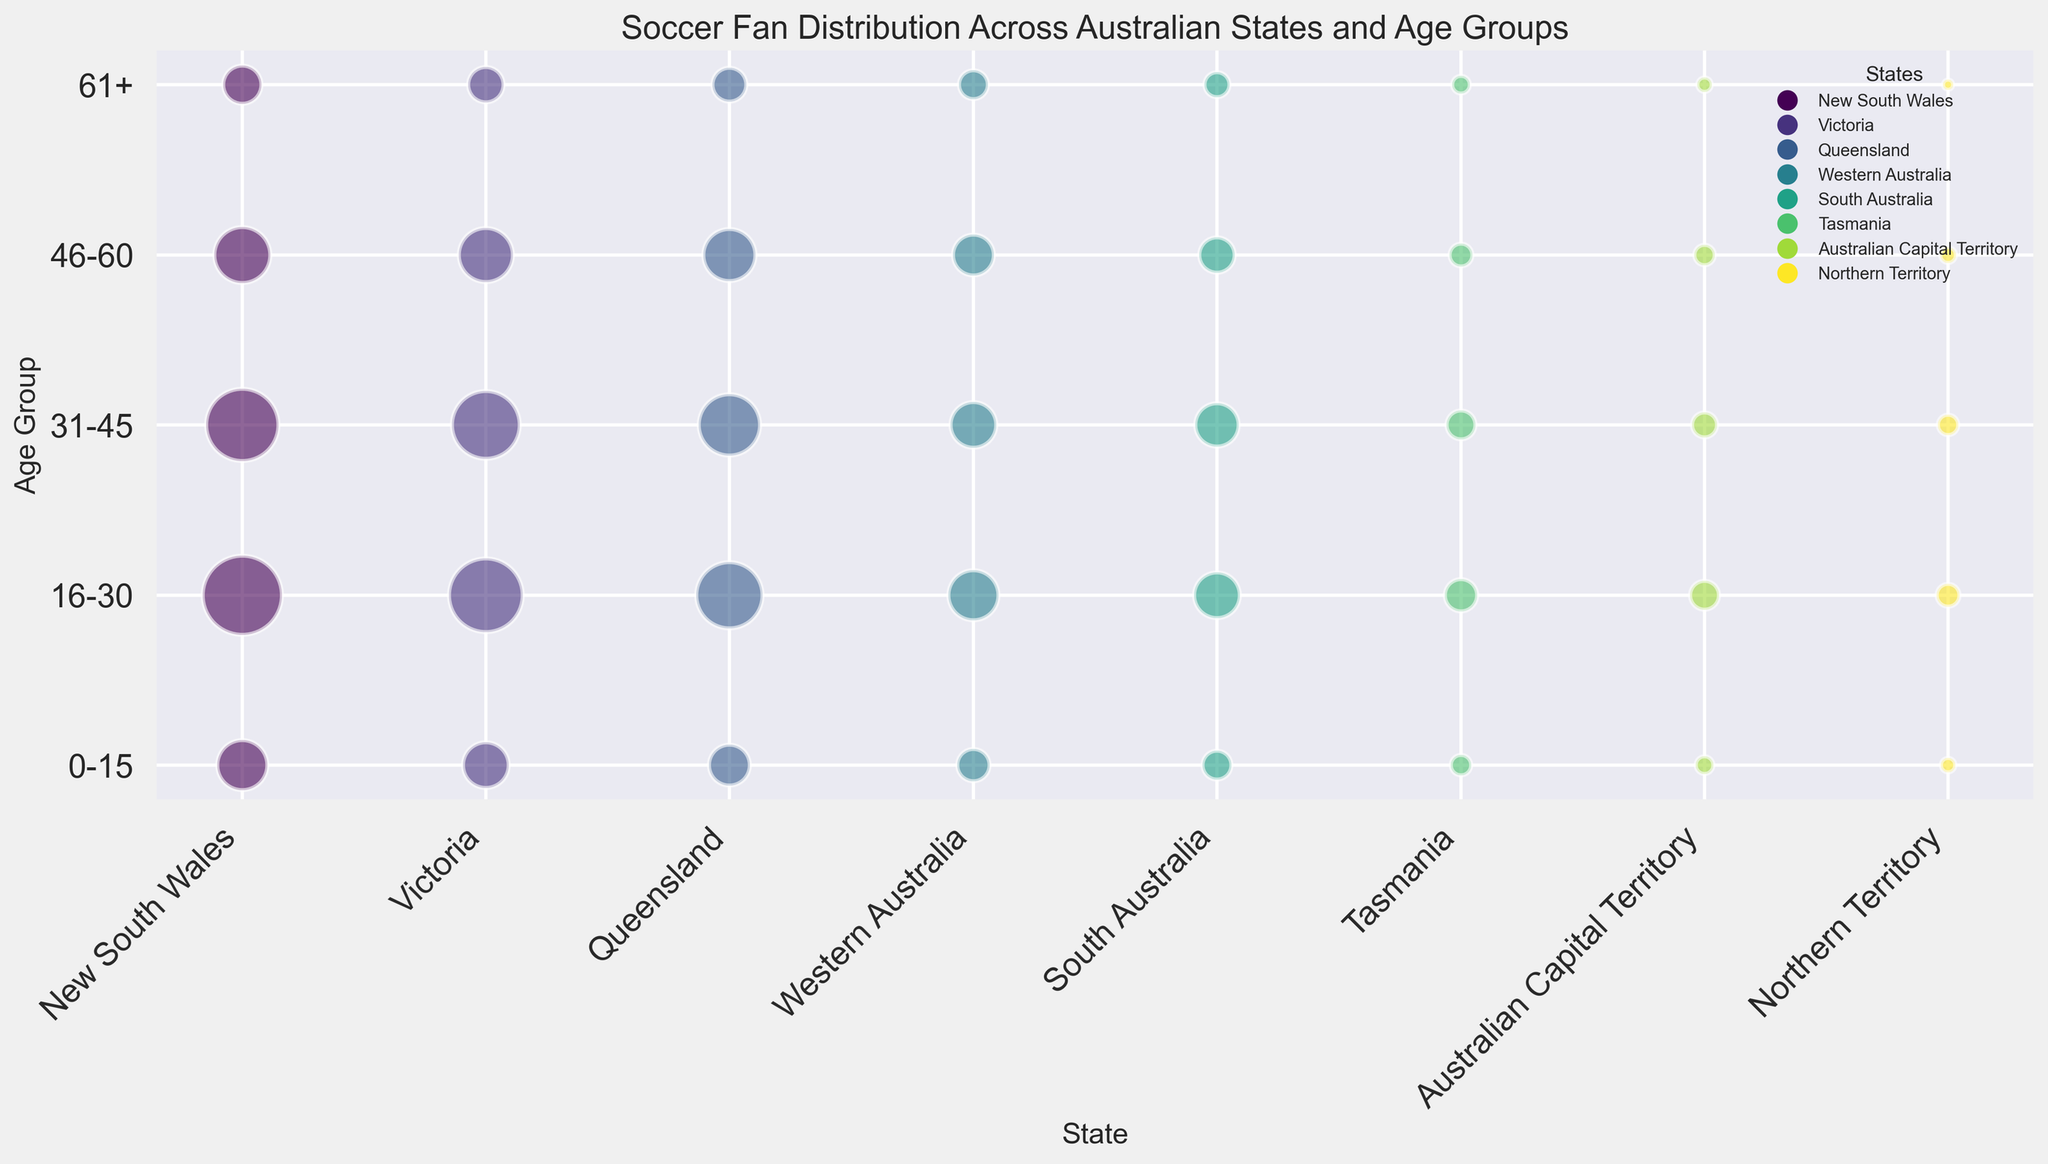Which state has the highest number of soccer fans in the 16-30 age group? Looking at the bubble sizes across all states for the 16-30 age group, New South Wales has the largest bubble, indicating the highest number of fans.
Answer: New South Wales What is the approximate total number of soccer fans in Queensland across all age groups? Sum up the number of fans in each age group for Queensland: 80,000 (0-15) + 210,000 (16-30) + 180,000 (31-45) + 130,000 (46-60) + 55,000 (61+).
Answer: 655,000 Compare the size of the bubbles for the age group 0-15 between New South Wales and Victoria. Which is larger? The bubble for New South Wales appears larger than the bubble for Victoria in the 0-15 age group.
Answer: New South Wales Which state has the smallest number of soccer fans in the 61+ age group? Looking at the smallest bubbles in the 61+ age group, the Northern Territory has the smallest bubble.
Answer: Northern Territory Is the number of soccer fans in the 31-45 age group in South Australia greater than the number in Tasmania's 16-30 age group? Compare the bubbles for the 31-45 age group in South Australia and the 16-30 age group in Tasmania. South Australia's bubble is larger at 90,000 compared to Tasmania’s 50,000.
Answer: Yes Which state has the most evenly distributed number of soccer fans across all age groups? Find the state with similarly sized bubbles across all age groups. Victoria shows relatively even distribution without stark differences in bubble sizes.
Answer: Victoria What is the difference in the number of soccer fans in the 46-60 age group between Western Australia and the Australian Capital Territory? Subtract the number of fans in the 46-60 age group of the Australian Capital Territory from Western Australia: 80,000 - 20,000.
Answer: 60,000 What is the visual attribute that represents the number of fans in the bubble chart? The size of each bubble represents the number of fans; larger bubbles indicate more fans.
Answer: Bubble size 